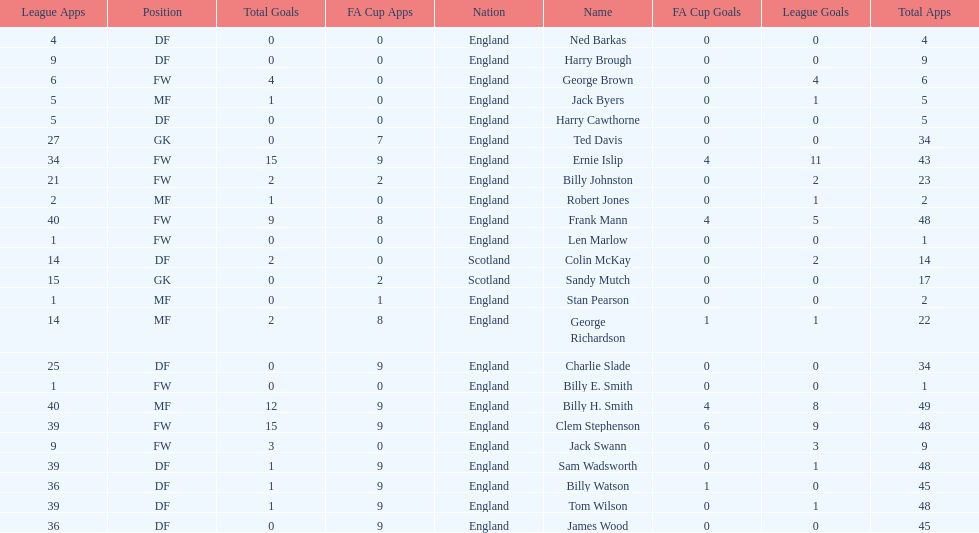Average number of goals scored by players from scotland 1. 